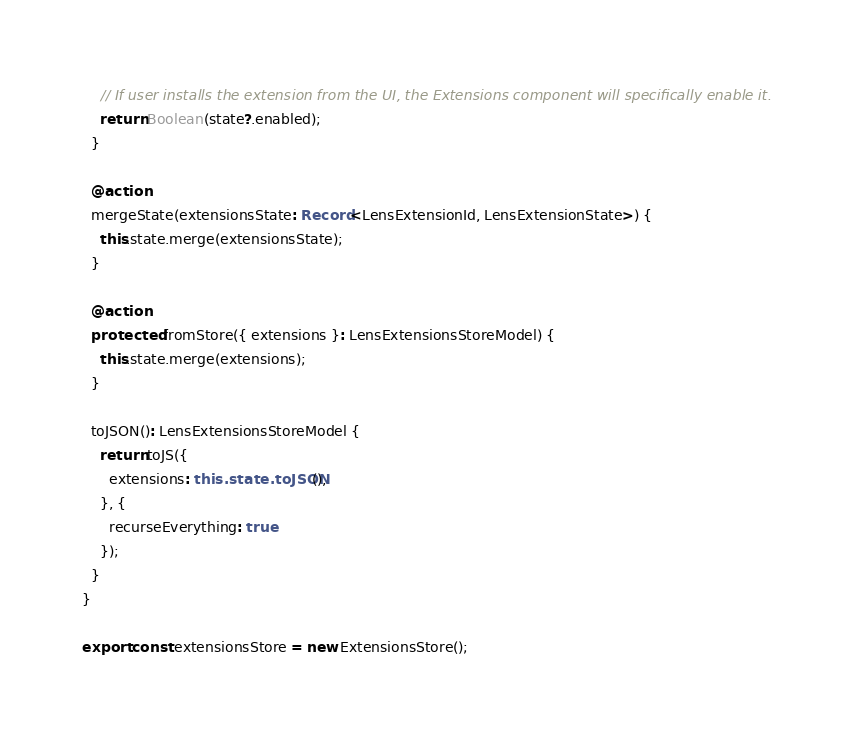<code> <loc_0><loc_0><loc_500><loc_500><_TypeScript_>    // If user installs the extension from the UI, the Extensions component will specifically enable it.
    return Boolean(state?.enabled);
  }

  @action
  mergeState(extensionsState: Record<LensExtensionId, LensExtensionState>) {
    this.state.merge(extensionsState);
  }

  @action
  protected fromStore({ extensions }: LensExtensionsStoreModel) {
    this.state.merge(extensions);
  }

  toJSON(): LensExtensionsStoreModel {
    return toJS({
      extensions: this.state.toJSON(),
    }, {
      recurseEverything: true
    });
  }
}

export const extensionsStore = new ExtensionsStore();
</code> 